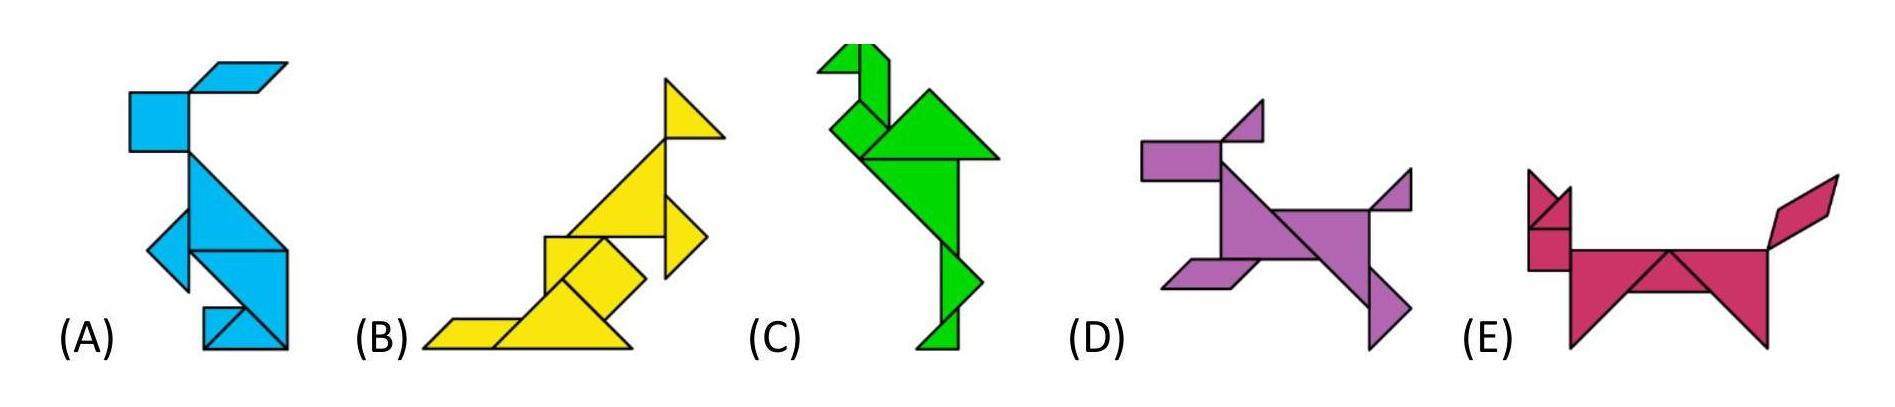How could these shapes be used as a learning tool for children? These shapes can serve as an excellent learning resource for children in several ways. They help in teaching geometric concepts, such as recognizing different shapes and understanding how they can be combined to form complex figures. Additionally, by using animal representations, they can also assist in developing cognitive skills like pattern recognition and categorization. Furthermore, assigning a unique color to each shape-animal combination can enhance memory retention and aid in teaching colors. The playful aspect of animals depicted in such an abstract form can also spark creativity and imagination among young learners. 